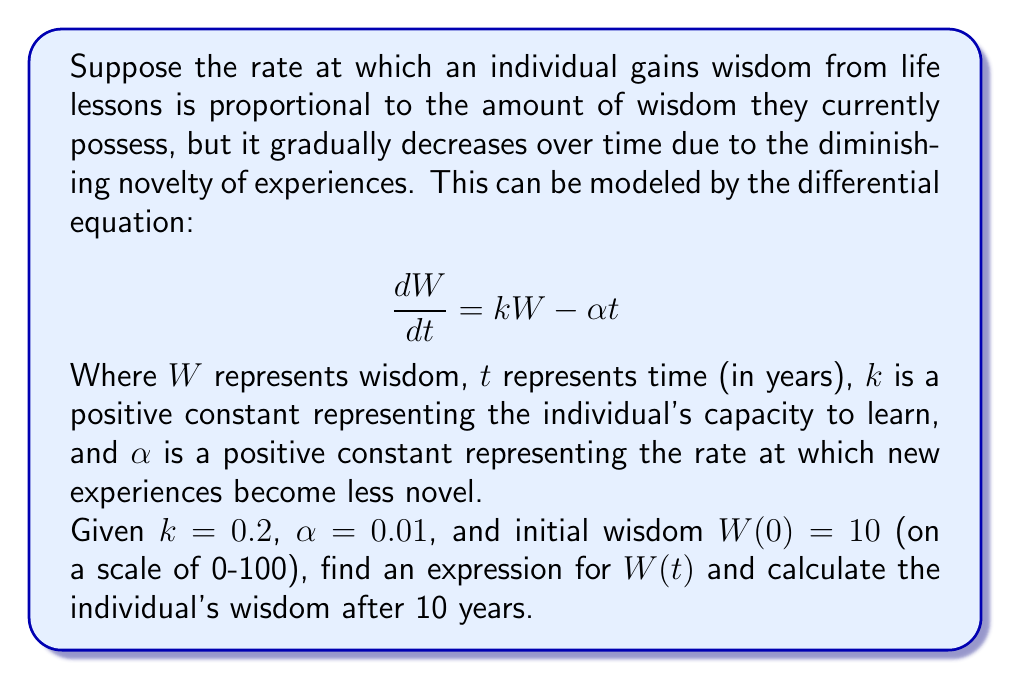What is the answer to this math problem? To solve this first-order linear differential equation, we'll use the integrating factor method:

1) The equation is in the form: $\frac{dW}{dt} + (-k)W = -\alpha t$

2) The integrating factor is $\mu(t) = e^{\int -k dt} = e^{-kt}$

3) Multiply both sides of the equation by $\mu(t)$:

   $e^{-kt}\frac{dW}{dt} + (-k)e^{-kt}W = -\alpha te^{-kt}$

4) The left side is now the derivative of $e^{-kt}W$:

   $\frac{d}{dt}(e^{-kt}W) = -\alpha te^{-kt}$

5) Integrate both sides:

   $e^{-kt}W = -\alpha \int te^{-kt}dt = \alpha(\frac{t}{k}+\frac{1}{k^2})e^{-kt} + C$

6) Solve for W:

   $W = \alpha(\frac{t}{k}+\frac{1}{k^2}) + Ce^{kt}$

7) Use the initial condition $W(0) = 10$ to find C:

   $10 = \alpha(\frac{0}{k}+\frac{1}{k^2}) + C$
   $C = 10 - \frac{\alpha}{k^2}$

8) Substitute the values $k = 0.2$ and $\alpha = 0.01$:

   $W(t) = 0.01(\frac{t}{0.2}+\frac{1}{0.2^2}) + (10 - \frac{0.01}{0.2^2})e^{0.2t}$
   
   $W(t) = 0.05t + 0.25 + 9.75e^{0.2t}$

9) To find wisdom after 10 years, calculate $W(10)$:

   $W(10) = 0.05(10) + 0.25 + 9.75e^{0.2(10)}$
   $= 0.5 + 0.25 + 9.75e^2$
   $\approx 73.24$
Answer: $W(t) = 0.05t + 0.25 + 9.75e^{0.2t}$

After 10 years, $W(10) \approx 73.24$ 